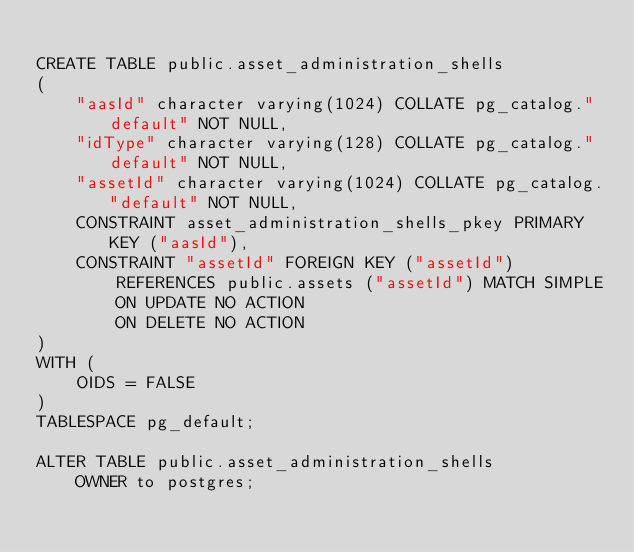<code> <loc_0><loc_0><loc_500><loc_500><_SQL_>
CREATE TABLE public.asset_administration_shells
(
    "aasId" character varying(1024) COLLATE pg_catalog."default" NOT NULL,
    "idType" character varying(128) COLLATE pg_catalog."default" NOT NULL,
    "assetId" character varying(1024) COLLATE pg_catalog."default" NOT NULL,
    CONSTRAINT asset_administration_shells_pkey PRIMARY KEY ("aasId"),
    CONSTRAINT "assetId" FOREIGN KEY ("assetId")
        REFERENCES public.assets ("assetId") MATCH SIMPLE
        ON UPDATE NO ACTION
        ON DELETE NO ACTION
)
WITH (
    OIDS = FALSE
)
TABLESPACE pg_default;

ALTER TABLE public.asset_administration_shells
    OWNER to postgres;
</code> 